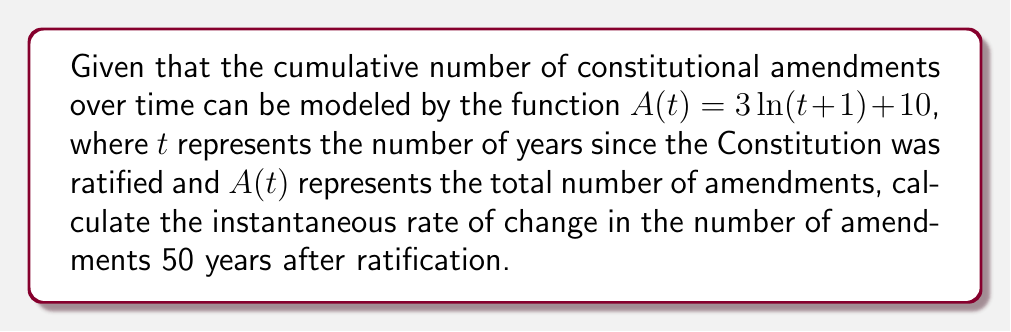Can you solve this math problem? To find the instantaneous rate of change in the number of amendments at a specific point in time, we need to calculate the derivative of the given function and evaluate it at the specified time.

Step 1: Find the derivative of $A(t)$
$$\frac{d}{dt}A(t) = \frac{d}{dt}(3\ln(t+1) + 10)$$
Using the chain rule:
$$A'(t) = 3 \cdot \frac{1}{t+1} \cdot \frac{d}{dt}(t+1)$$
$$A'(t) = 3 \cdot \frac{1}{t+1} \cdot 1$$
$$A'(t) = \frac{3}{t+1}$$

Step 2: Evaluate the derivative at $t = 50$
$$A'(50) = \frac{3}{50+1} = \frac{3}{51}$$

Step 3: Simplify the fraction
$$\frac{3}{51} = \frac{1}{17}$$

Therefore, the instantaneous rate of change in the number of amendments 50 years after ratification is $\frac{1}{17}$ amendments per year.
Answer: $\frac{1}{17}$ amendments per year 